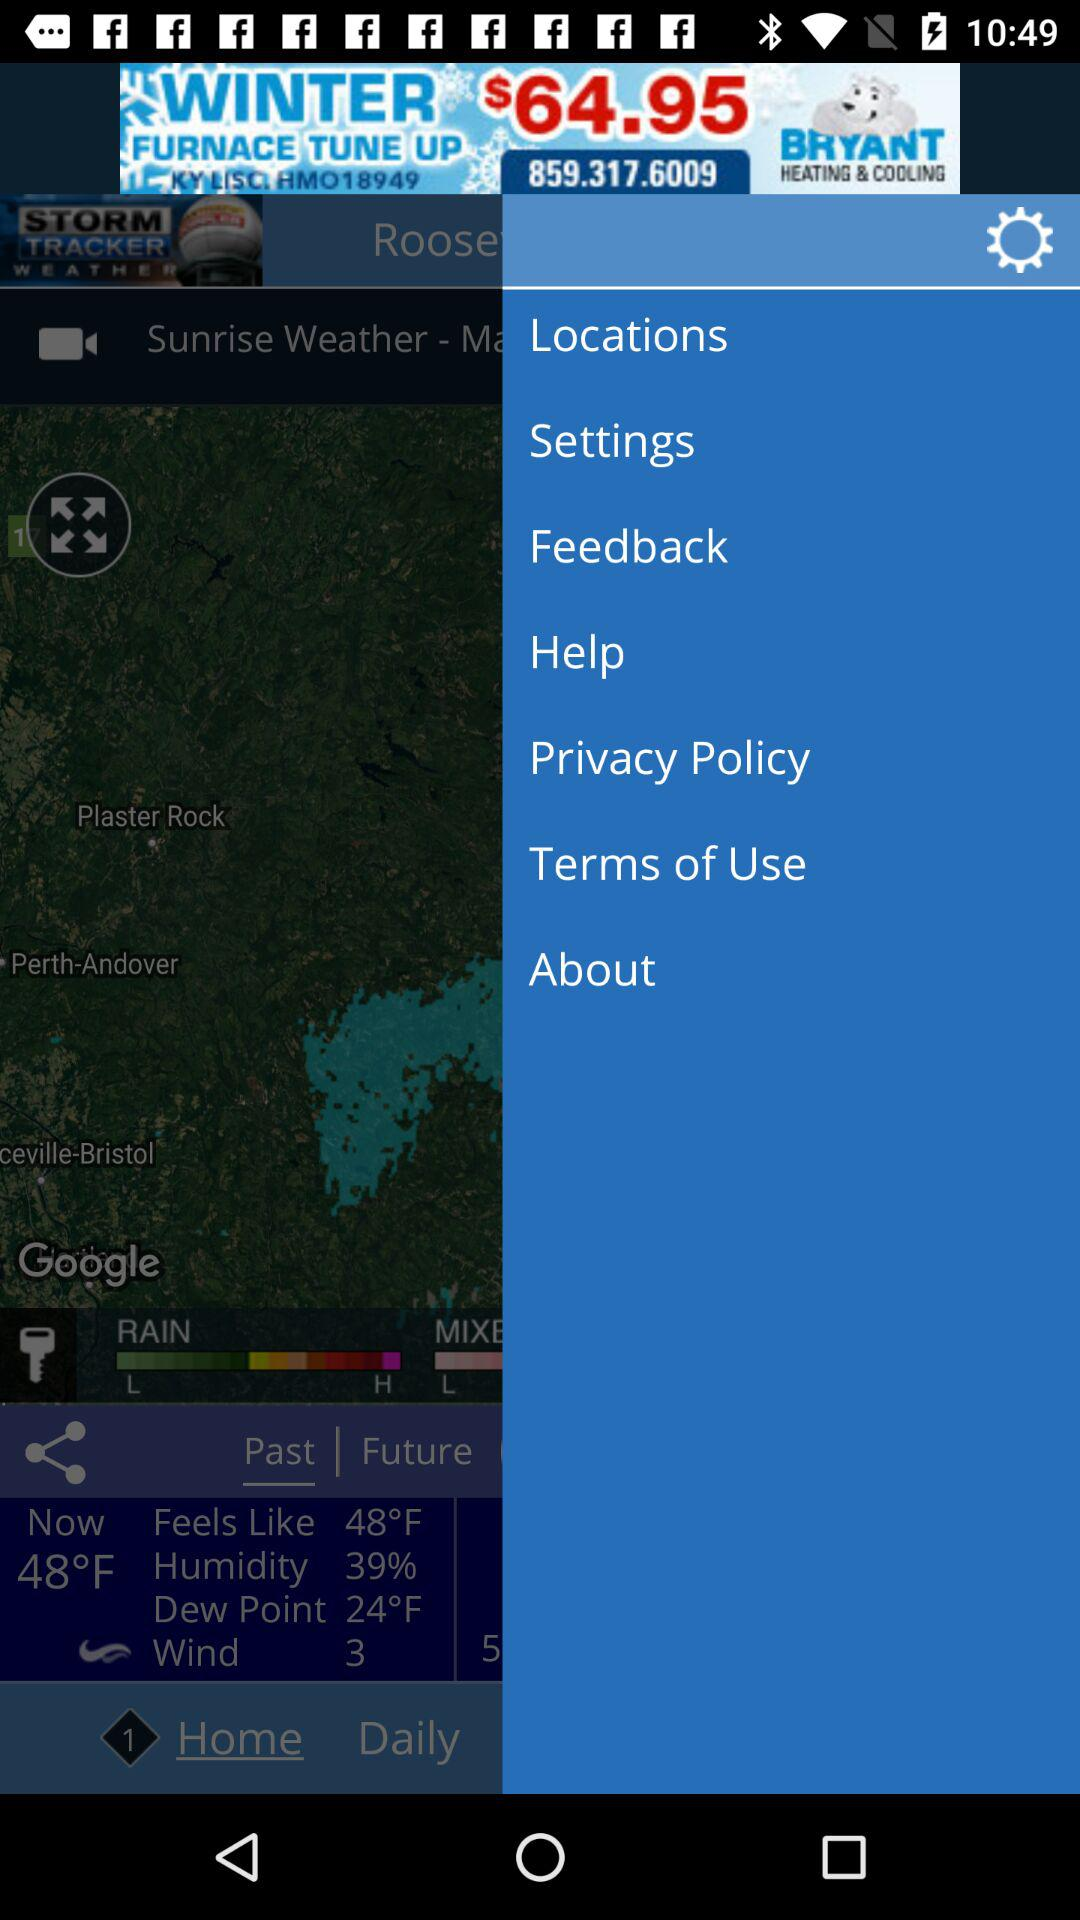How many degrees Fahrenheit is the difference between the current temperature and the dew point?
Answer the question using a single word or phrase. 24 